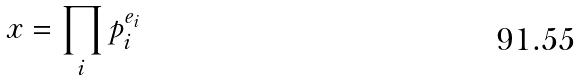<formula> <loc_0><loc_0><loc_500><loc_500>x = \prod _ { i } p _ { i } ^ { e _ { i } }</formula> 